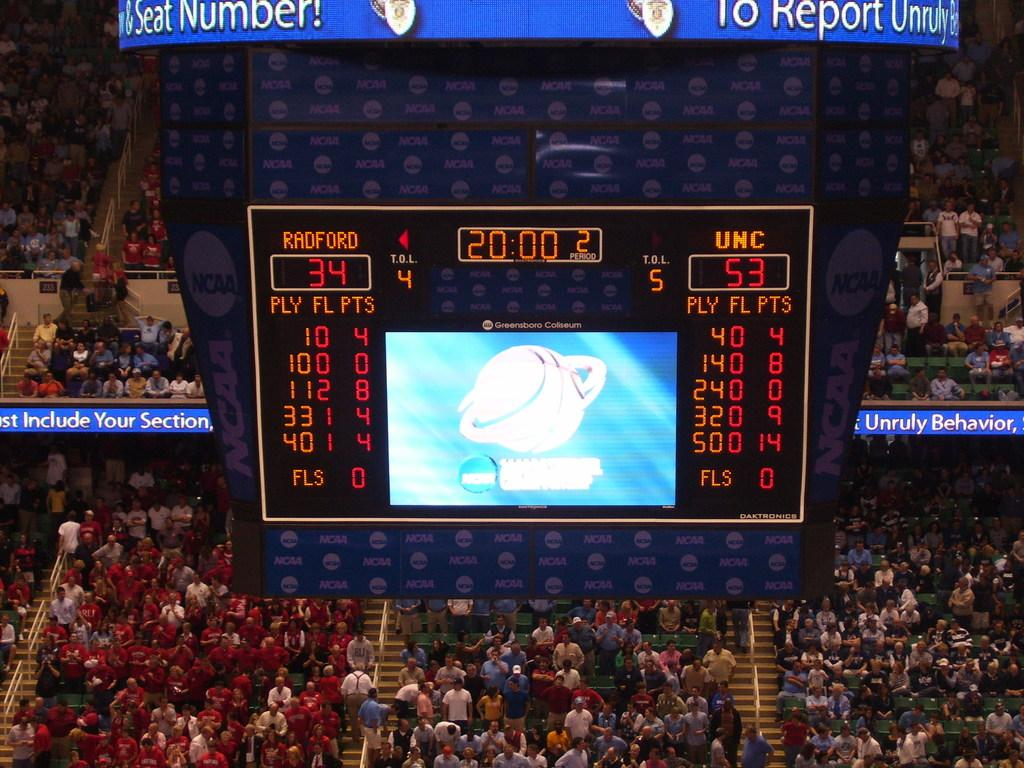<image>
Provide a brief description of the given image. A score board for a game between radford versus UNC teams. 